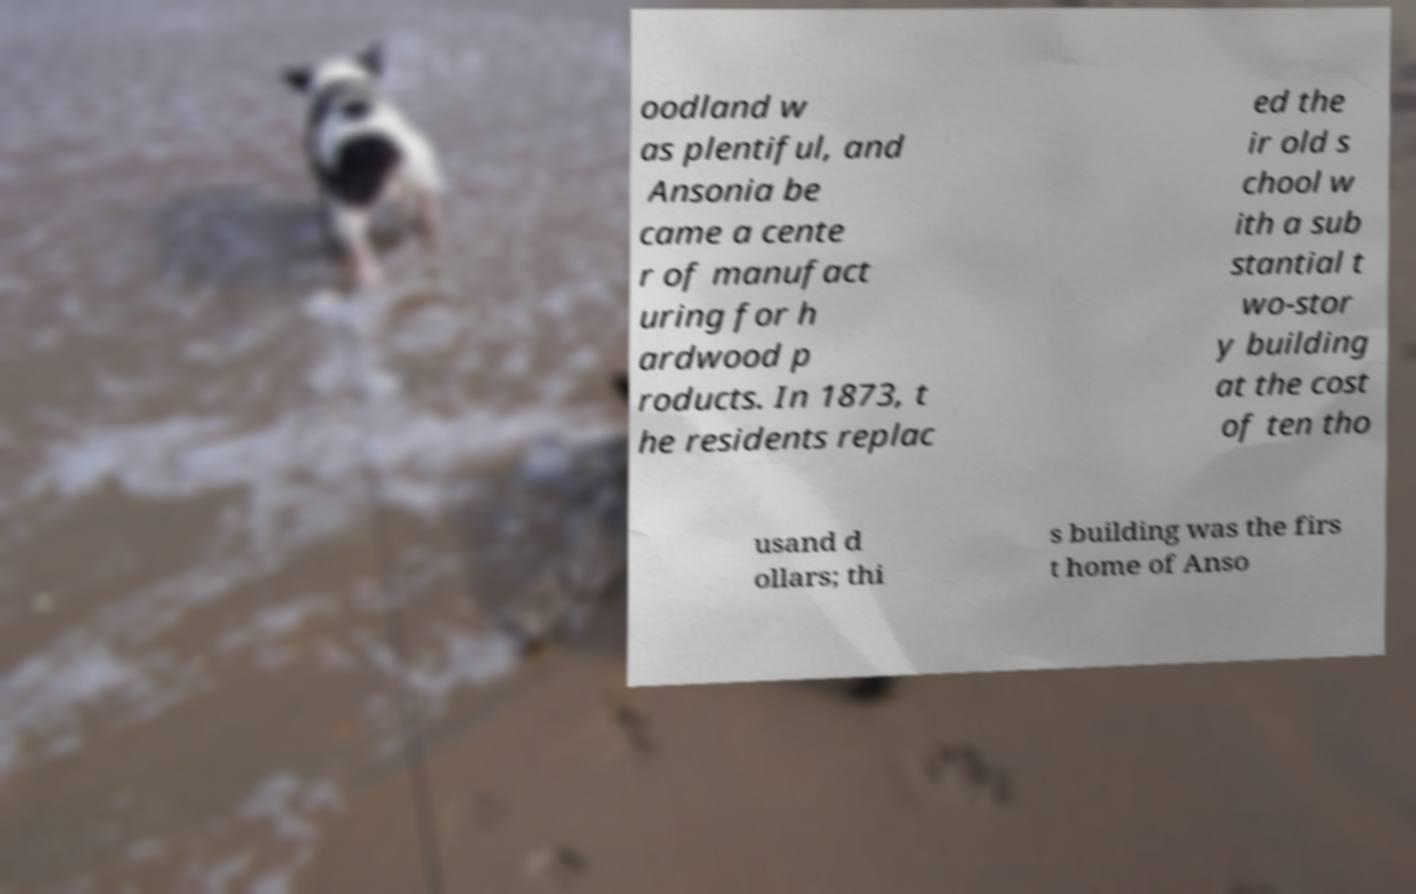Please read and relay the text visible in this image. What does it say? oodland w as plentiful, and Ansonia be came a cente r of manufact uring for h ardwood p roducts. In 1873, t he residents replac ed the ir old s chool w ith a sub stantial t wo-stor y building at the cost of ten tho usand d ollars; thi s building was the firs t home of Anso 